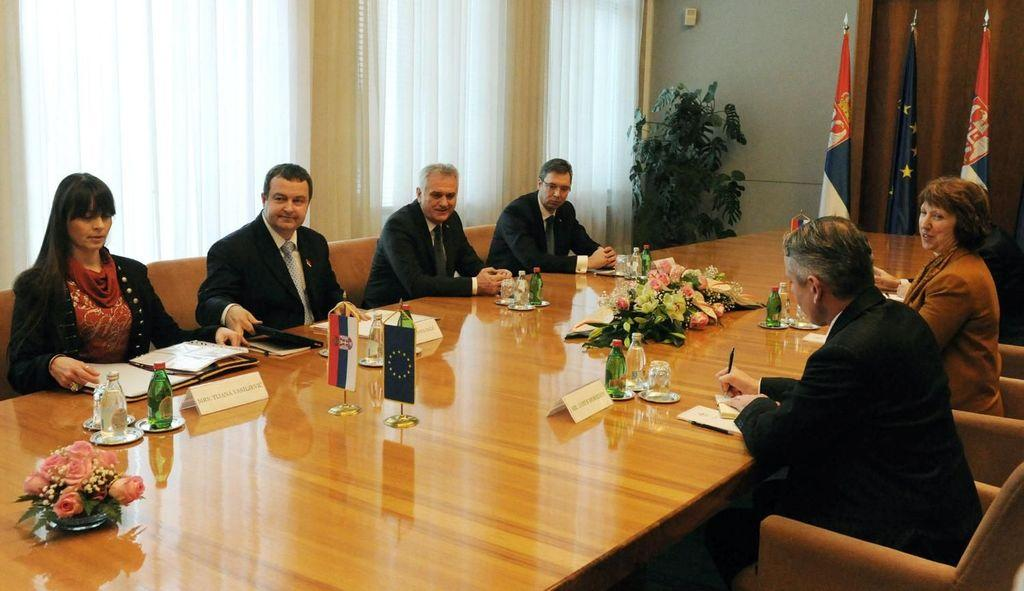What are the people in the image doing? The people in the image are sitting on chairs. What can be seen on the table in the image? There are flags and bottles on the table. Can you describe the background of the image? There is a plant in the background of the image. How many flags are visible in the background? There are three flags in the background of the image. What is the average income of the people in the image? There is no information about the income of the people in the image. Where is the library located in the image? There is no library present in the image. 